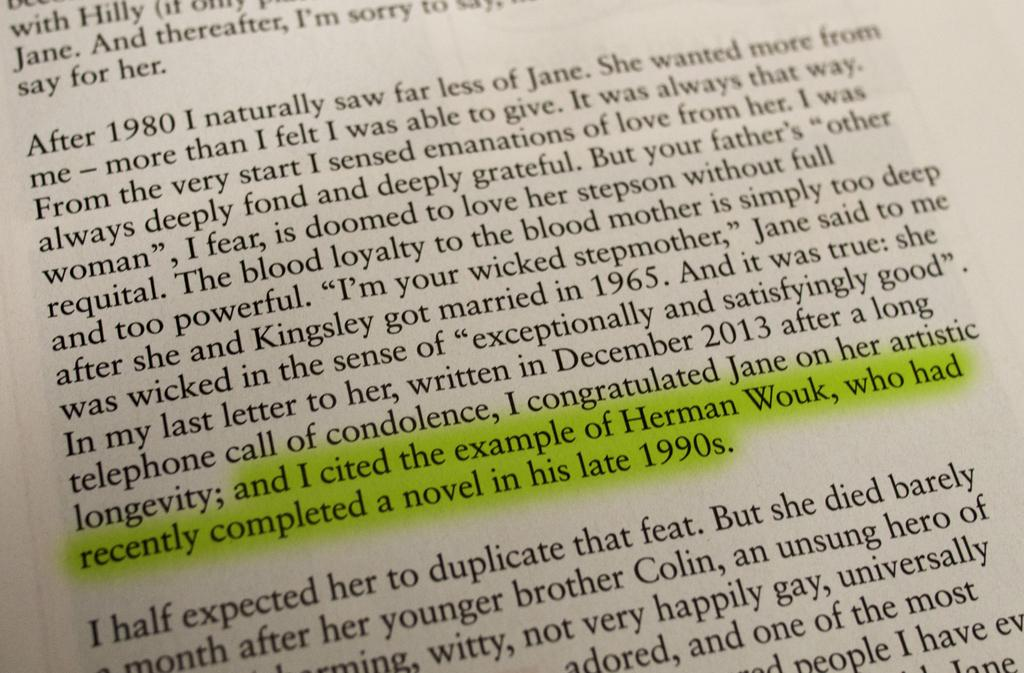<image>
Summarize the visual content of the image. Someone has highlighted a sentence in a book that ends with "late 1990s". 